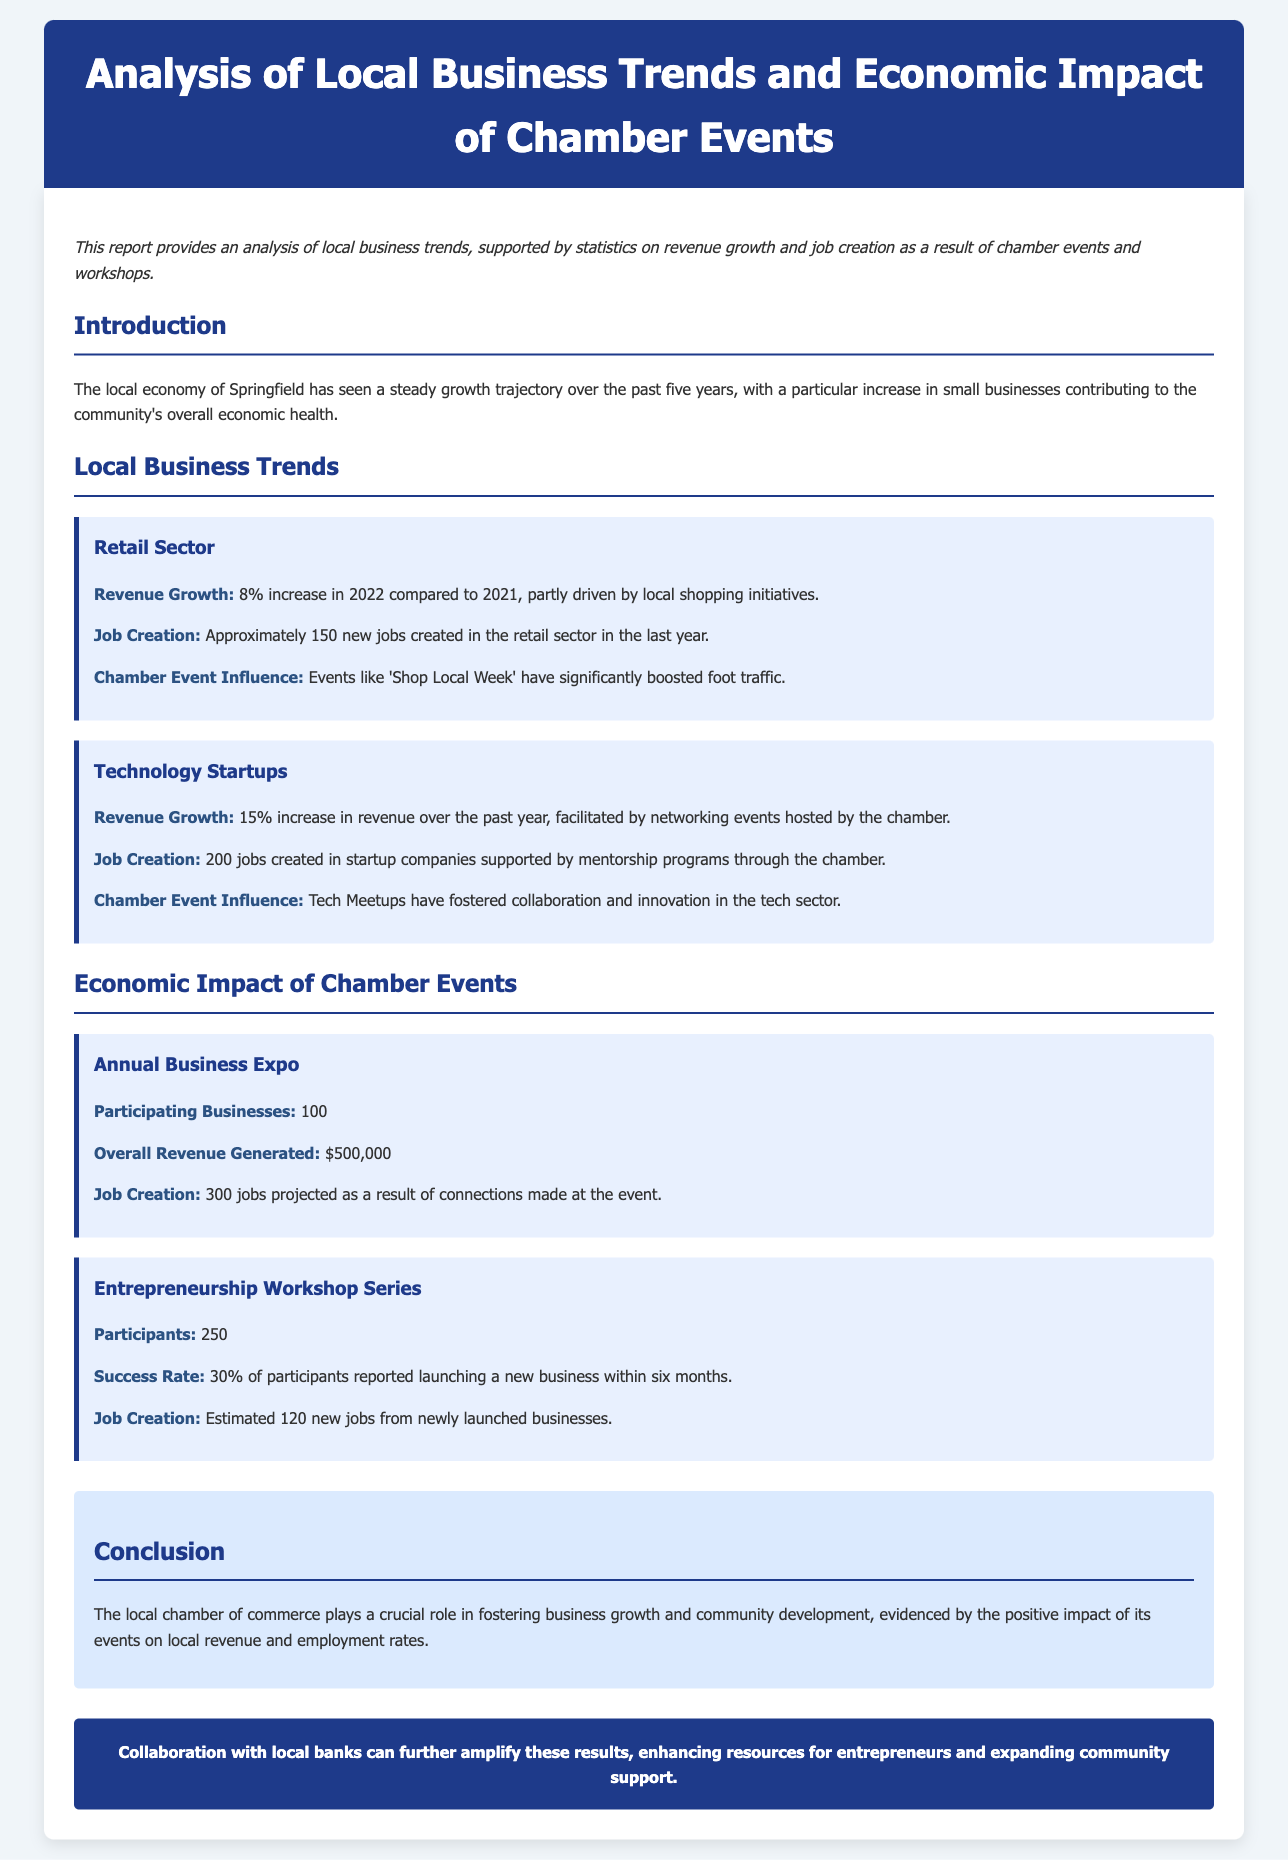What was the revenue growth percentage in the retail sector for 2022? The document states that the revenue growth in the retail sector was an 8% increase in 2022 compared to 2021.
Answer: 8% How many new jobs were created in technology startups? The document mentions that 200 jobs were created in startup companies supported by mentorship programs.
Answer: 200 What was the overall revenue generated by the Annual Business Expo? According to the document, the overall revenue generated by the event was $500,000.
Answer: $500,000 What percentage of entrepreneurship workshop participants reported launching a new business? The document indicates that 30% of participants reported launching a new business within six months.
Answer: 30% How many participants were there in the Entrepreneurship Workshop Series? The document states that there were 250 participants in the Entrepreneurship Workshop Series.
Answer: 250 What is the estimated number of new jobs from newly launched businesses? The document reports an estimated 120 new jobs from newly launched businesses.
Answer: 120 What factor significantly boosted foot traffic in the retail sector? Events like 'Shop Local Week' have significantly boosted foot traffic according to the document.
Answer: 'Shop Local Week' How many jobs are projected to be created from the Annual Business Expo? The document states that 300 jobs are projected as a result of connections made at the Annual Business Expo.
Answer: 300 What role does the local chamber of commerce play according to the conclusion? The conclusion highlights that the local chamber of commerce plays a crucial role in fostering business growth and community development.
Answer: Business growth and community development 